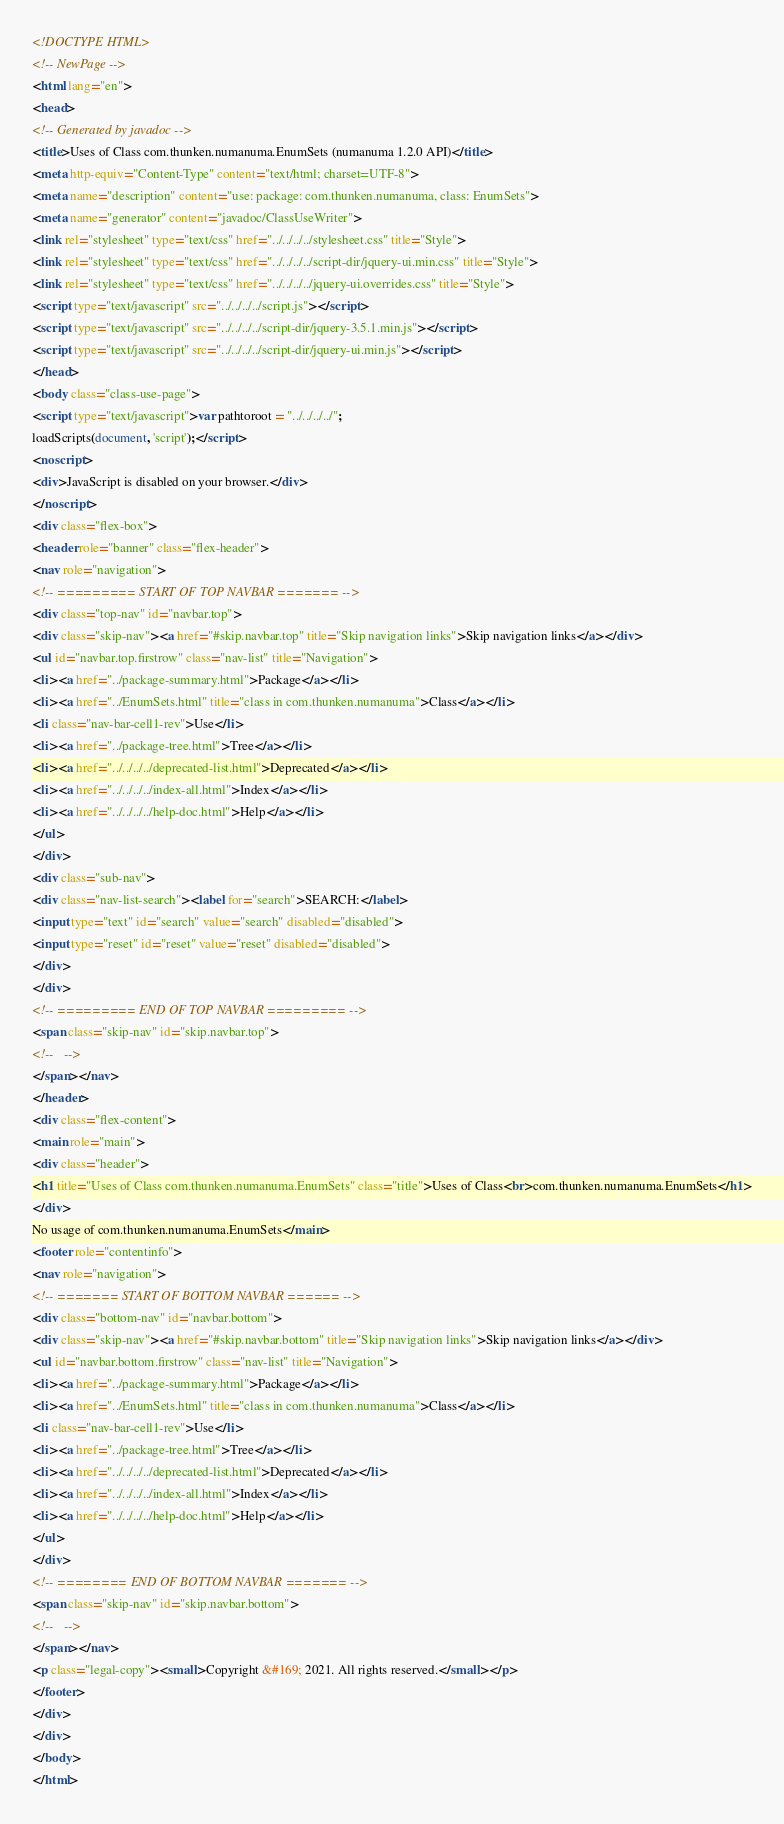<code> <loc_0><loc_0><loc_500><loc_500><_HTML_><!DOCTYPE HTML>
<!-- NewPage -->
<html lang="en">
<head>
<!-- Generated by javadoc -->
<title>Uses of Class com.thunken.numanuma.EnumSets (numanuma 1.2.0 API)</title>
<meta http-equiv="Content-Type" content="text/html; charset=UTF-8">
<meta name="description" content="use: package: com.thunken.numanuma, class: EnumSets">
<meta name="generator" content="javadoc/ClassUseWriter">
<link rel="stylesheet" type="text/css" href="../../../../stylesheet.css" title="Style">
<link rel="stylesheet" type="text/css" href="../../../../script-dir/jquery-ui.min.css" title="Style">
<link rel="stylesheet" type="text/css" href="../../../../jquery-ui.overrides.css" title="Style">
<script type="text/javascript" src="../../../../script.js"></script>
<script type="text/javascript" src="../../../../script-dir/jquery-3.5.1.min.js"></script>
<script type="text/javascript" src="../../../../script-dir/jquery-ui.min.js"></script>
</head>
<body class="class-use-page">
<script type="text/javascript">var pathtoroot = "../../../../";
loadScripts(document, 'script');</script>
<noscript>
<div>JavaScript is disabled on your browser.</div>
</noscript>
<div class="flex-box">
<header role="banner" class="flex-header">
<nav role="navigation">
<!-- ========= START OF TOP NAVBAR ======= -->
<div class="top-nav" id="navbar.top">
<div class="skip-nav"><a href="#skip.navbar.top" title="Skip navigation links">Skip navigation links</a></div>
<ul id="navbar.top.firstrow" class="nav-list" title="Navigation">
<li><a href="../package-summary.html">Package</a></li>
<li><a href="../EnumSets.html" title="class in com.thunken.numanuma">Class</a></li>
<li class="nav-bar-cell1-rev">Use</li>
<li><a href="../package-tree.html">Tree</a></li>
<li><a href="../../../../deprecated-list.html">Deprecated</a></li>
<li><a href="../../../../index-all.html">Index</a></li>
<li><a href="../../../../help-doc.html">Help</a></li>
</ul>
</div>
<div class="sub-nav">
<div class="nav-list-search"><label for="search">SEARCH:</label>
<input type="text" id="search" value="search" disabled="disabled">
<input type="reset" id="reset" value="reset" disabled="disabled">
</div>
</div>
<!-- ========= END OF TOP NAVBAR ========= -->
<span class="skip-nav" id="skip.navbar.top">
<!--   -->
</span></nav>
</header>
<div class="flex-content">
<main role="main">
<div class="header">
<h1 title="Uses of Class com.thunken.numanuma.EnumSets" class="title">Uses of Class<br>com.thunken.numanuma.EnumSets</h1>
</div>
No usage of com.thunken.numanuma.EnumSets</main>
<footer role="contentinfo">
<nav role="navigation">
<!-- ======= START OF BOTTOM NAVBAR ====== -->
<div class="bottom-nav" id="navbar.bottom">
<div class="skip-nav"><a href="#skip.navbar.bottom" title="Skip navigation links">Skip navigation links</a></div>
<ul id="navbar.bottom.firstrow" class="nav-list" title="Navigation">
<li><a href="../package-summary.html">Package</a></li>
<li><a href="../EnumSets.html" title="class in com.thunken.numanuma">Class</a></li>
<li class="nav-bar-cell1-rev">Use</li>
<li><a href="../package-tree.html">Tree</a></li>
<li><a href="../../../../deprecated-list.html">Deprecated</a></li>
<li><a href="../../../../index-all.html">Index</a></li>
<li><a href="../../../../help-doc.html">Help</a></li>
</ul>
</div>
<!-- ======== END OF BOTTOM NAVBAR ======= -->
<span class="skip-nav" id="skip.navbar.bottom">
<!--   -->
</span></nav>
<p class="legal-copy"><small>Copyright &#169; 2021. All rights reserved.</small></p>
</footer>
</div>
</div>
</body>
</html>
</code> 